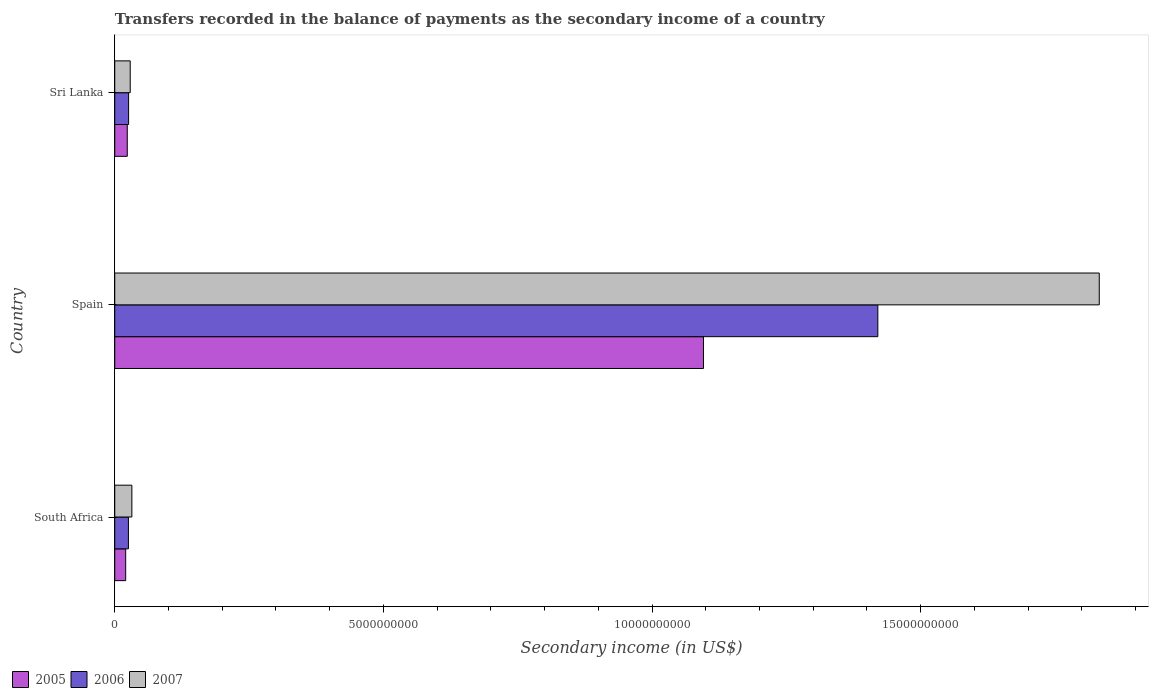How many different coloured bars are there?
Your answer should be compact. 3. How many groups of bars are there?
Your answer should be compact. 3. Are the number of bars on each tick of the Y-axis equal?
Give a very brief answer. Yes. How many bars are there on the 3rd tick from the top?
Keep it short and to the point. 3. What is the label of the 2nd group of bars from the top?
Ensure brevity in your answer.  Spain. What is the secondary income of in 2007 in Sri Lanka?
Your answer should be compact. 2.88e+08. Across all countries, what is the maximum secondary income of in 2005?
Provide a short and direct response. 1.10e+1. Across all countries, what is the minimum secondary income of in 2006?
Provide a succinct answer. 2.54e+08. In which country was the secondary income of in 2006 minimum?
Offer a terse response. South Africa. What is the total secondary income of in 2006 in the graph?
Provide a succinct answer. 1.47e+1. What is the difference between the secondary income of in 2006 in South Africa and that in Sri Lanka?
Offer a very short reply. -3.11e+06. What is the difference between the secondary income of in 2006 in Sri Lanka and the secondary income of in 2005 in South Africa?
Your response must be concise. 5.41e+07. What is the average secondary income of in 2006 per country?
Your response must be concise. 4.91e+09. What is the difference between the secondary income of in 2006 and secondary income of in 2005 in Spain?
Offer a very short reply. 3.25e+09. In how many countries, is the secondary income of in 2006 greater than 4000000000 US$?
Make the answer very short. 1. What is the ratio of the secondary income of in 2005 in Spain to that in Sri Lanka?
Offer a terse response. 47.05. Is the secondary income of in 2006 in South Africa less than that in Spain?
Provide a short and direct response. Yes. Is the difference between the secondary income of in 2006 in South Africa and Sri Lanka greater than the difference between the secondary income of in 2005 in South Africa and Sri Lanka?
Offer a terse response. Yes. What is the difference between the highest and the second highest secondary income of in 2005?
Your answer should be compact. 1.07e+1. What is the difference between the highest and the lowest secondary income of in 2007?
Provide a short and direct response. 1.80e+1. Is the sum of the secondary income of in 2005 in Spain and Sri Lanka greater than the maximum secondary income of in 2007 across all countries?
Give a very brief answer. No. How many countries are there in the graph?
Offer a very short reply. 3. Does the graph contain any zero values?
Provide a succinct answer. No. Where does the legend appear in the graph?
Keep it short and to the point. Bottom left. How are the legend labels stacked?
Your answer should be compact. Horizontal. What is the title of the graph?
Offer a terse response. Transfers recorded in the balance of payments as the secondary income of a country. Does "1987" appear as one of the legend labels in the graph?
Provide a short and direct response. No. What is the label or title of the X-axis?
Your answer should be very brief. Secondary income (in US$). What is the Secondary income (in US$) of 2005 in South Africa?
Provide a succinct answer. 2.03e+08. What is the Secondary income (in US$) in 2006 in South Africa?
Give a very brief answer. 2.54e+08. What is the Secondary income (in US$) of 2007 in South Africa?
Provide a short and direct response. 3.19e+08. What is the Secondary income (in US$) of 2005 in Spain?
Your response must be concise. 1.10e+1. What is the Secondary income (in US$) in 2006 in Spain?
Offer a very short reply. 1.42e+1. What is the Secondary income (in US$) of 2007 in Spain?
Ensure brevity in your answer.  1.83e+1. What is the Secondary income (in US$) in 2005 in Sri Lanka?
Ensure brevity in your answer.  2.33e+08. What is the Secondary income (in US$) of 2006 in Sri Lanka?
Make the answer very short. 2.58e+08. What is the Secondary income (in US$) in 2007 in Sri Lanka?
Your answer should be very brief. 2.88e+08. Across all countries, what is the maximum Secondary income (in US$) in 2005?
Your answer should be compact. 1.10e+1. Across all countries, what is the maximum Secondary income (in US$) in 2006?
Give a very brief answer. 1.42e+1. Across all countries, what is the maximum Secondary income (in US$) of 2007?
Your answer should be very brief. 1.83e+1. Across all countries, what is the minimum Secondary income (in US$) in 2005?
Offer a terse response. 2.03e+08. Across all countries, what is the minimum Secondary income (in US$) of 2006?
Keep it short and to the point. 2.54e+08. Across all countries, what is the minimum Secondary income (in US$) in 2007?
Make the answer very short. 2.88e+08. What is the total Secondary income (in US$) in 2005 in the graph?
Provide a succinct answer. 1.14e+1. What is the total Secondary income (in US$) in 2006 in the graph?
Offer a very short reply. 1.47e+1. What is the total Secondary income (in US$) in 2007 in the graph?
Offer a very short reply. 1.89e+1. What is the difference between the Secondary income (in US$) of 2005 in South Africa and that in Spain?
Keep it short and to the point. -1.08e+1. What is the difference between the Secondary income (in US$) in 2006 in South Africa and that in Spain?
Keep it short and to the point. -1.39e+1. What is the difference between the Secondary income (in US$) in 2007 in South Africa and that in Spain?
Offer a terse response. -1.80e+1. What is the difference between the Secondary income (in US$) in 2005 in South Africa and that in Sri Lanka?
Offer a very short reply. -2.95e+07. What is the difference between the Secondary income (in US$) of 2006 in South Africa and that in Sri Lanka?
Make the answer very short. -3.11e+06. What is the difference between the Secondary income (in US$) in 2007 in South Africa and that in Sri Lanka?
Ensure brevity in your answer.  3.10e+07. What is the difference between the Secondary income (in US$) in 2005 in Spain and that in Sri Lanka?
Provide a short and direct response. 1.07e+1. What is the difference between the Secondary income (in US$) in 2006 in Spain and that in Sri Lanka?
Your response must be concise. 1.39e+1. What is the difference between the Secondary income (in US$) of 2007 in Spain and that in Sri Lanka?
Your answer should be very brief. 1.80e+1. What is the difference between the Secondary income (in US$) of 2005 in South Africa and the Secondary income (in US$) of 2006 in Spain?
Make the answer very short. -1.40e+1. What is the difference between the Secondary income (in US$) in 2005 in South Africa and the Secondary income (in US$) in 2007 in Spain?
Your answer should be compact. -1.81e+1. What is the difference between the Secondary income (in US$) in 2006 in South Africa and the Secondary income (in US$) in 2007 in Spain?
Keep it short and to the point. -1.81e+1. What is the difference between the Secondary income (in US$) of 2005 in South Africa and the Secondary income (in US$) of 2006 in Sri Lanka?
Give a very brief answer. -5.41e+07. What is the difference between the Secondary income (in US$) of 2005 in South Africa and the Secondary income (in US$) of 2007 in Sri Lanka?
Offer a terse response. -8.44e+07. What is the difference between the Secondary income (in US$) in 2006 in South Africa and the Secondary income (in US$) in 2007 in Sri Lanka?
Give a very brief answer. -3.34e+07. What is the difference between the Secondary income (in US$) of 2005 in Spain and the Secondary income (in US$) of 2006 in Sri Lanka?
Your answer should be very brief. 1.07e+1. What is the difference between the Secondary income (in US$) of 2005 in Spain and the Secondary income (in US$) of 2007 in Sri Lanka?
Your response must be concise. 1.07e+1. What is the difference between the Secondary income (in US$) in 2006 in Spain and the Secondary income (in US$) in 2007 in Sri Lanka?
Offer a terse response. 1.39e+1. What is the average Secondary income (in US$) in 2005 per country?
Offer a terse response. 3.80e+09. What is the average Secondary income (in US$) in 2006 per country?
Keep it short and to the point. 4.91e+09. What is the average Secondary income (in US$) in 2007 per country?
Offer a very short reply. 6.31e+09. What is the difference between the Secondary income (in US$) in 2005 and Secondary income (in US$) in 2006 in South Africa?
Your answer should be very brief. -5.10e+07. What is the difference between the Secondary income (in US$) of 2005 and Secondary income (in US$) of 2007 in South Africa?
Give a very brief answer. -1.15e+08. What is the difference between the Secondary income (in US$) in 2006 and Secondary income (in US$) in 2007 in South Africa?
Ensure brevity in your answer.  -6.44e+07. What is the difference between the Secondary income (in US$) of 2005 and Secondary income (in US$) of 2006 in Spain?
Keep it short and to the point. -3.25e+09. What is the difference between the Secondary income (in US$) in 2005 and Secondary income (in US$) in 2007 in Spain?
Make the answer very short. -7.37e+09. What is the difference between the Secondary income (in US$) of 2006 and Secondary income (in US$) of 2007 in Spain?
Offer a terse response. -4.12e+09. What is the difference between the Secondary income (in US$) in 2005 and Secondary income (in US$) in 2006 in Sri Lanka?
Make the answer very short. -2.46e+07. What is the difference between the Secondary income (in US$) of 2005 and Secondary income (in US$) of 2007 in Sri Lanka?
Provide a succinct answer. -5.48e+07. What is the difference between the Secondary income (in US$) of 2006 and Secondary income (in US$) of 2007 in Sri Lanka?
Provide a succinct answer. -3.02e+07. What is the ratio of the Secondary income (in US$) in 2005 in South Africa to that in Spain?
Offer a terse response. 0.02. What is the ratio of the Secondary income (in US$) of 2006 in South Africa to that in Spain?
Offer a very short reply. 0.02. What is the ratio of the Secondary income (in US$) of 2007 in South Africa to that in Spain?
Keep it short and to the point. 0.02. What is the ratio of the Secondary income (in US$) of 2005 in South Africa to that in Sri Lanka?
Offer a terse response. 0.87. What is the ratio of the Secondary income (in US$) in 2006 in South Africa to that in Sri Lanka?
Your answer should be compact. 0.99. What is the ratio of the Secondary income (in US$) of 2007 in South Africa to that in Sri Lanka?
Your answer should be compact. 1.11. What is the ratio of the Secondary income (in US$) of 2005 in Spain to that in Sri Lanka?
Give a very brief answer. 47.05. What is the ratio of the Secondary income (in US$) of 2006 in Spain to that in Sri Lanka?
Provide a short and direct response. 55.16. What is the ratio of the Secondary income (in US$) in 2007 in Spain to that in Sri Lanka?
Keep it short and to the point. 63.68. What is the difference between the highest and the second highest Secondary income (in US$) in 2005?
Ensure brevity in your answer.  1.07e+1. What is the difference between the highest and the second highest Secondary income (in US$) of 2006?
Offer a terse response. 1.39e+1. What is the difference between the highest and the second highest Secondary income (in US$) of 2007?
Keep it short and to the point. 1.80e+1. What is the difference between the highest and the lowest Secondary income (in US$) in 2005?
Offer a terse response. 1.08e+1. What is the difference between the highest and the lowest Secondary income (in US$) in 2006?
Your answer should be compact. 1.39e+1. What is the difference between the highest and the lowest Secondary income (in US$) in 2007?
Provide a short and direct response. 1.80e+1. 